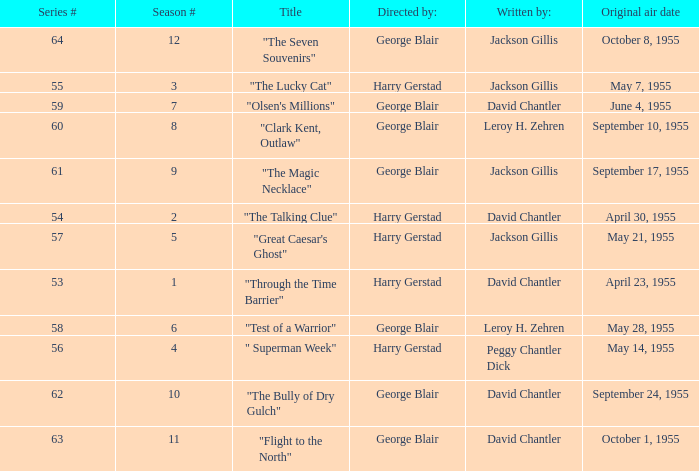What is the lowest number of series? 53.0. Give me the full table as a dictionary. {'header': ['Series #', 'Season #', 'Title', 'Directed by:', 'Written by:', 'Original air date'], 'rows': [['64', '12', '"The Seven Souvenirs"', 'George Blair', 'Jackson Gillis', 'October 8, 1955'], ['55', '3', '"The Lucky Cat"', 'Harry Gerstad', 'Jackson Gillis', 'May 7, 1955'], ['59', '7', '"Olsen\'s Millions"', 'George Blair', 'David Chantler', 'June 4, 1955'], ['60', '8', '"Clark Kent, Outlaw"', 'George Blair', 'Leroy H. Zehren', 'September 10, 1955'], ['61', '9', '"The Magic Necklace"', 'George Blair', 'Jackson Gillis', 'September 17, 1955'], ['54', '2', '"The Talking Clue"', 'Harry Gerstad', 'David Chantler', 'April 30, 1955'], ['57', '5', '"Great Caesar\'s Ghost"', 'Harry Gerstad', 'Jackson Gillis', 'May 21, 1955'], ['53', '1', '"Through the Time Barrier"', 'Harry Gerstad', 'David Chantler', 'April 23, 1955'], ['58', '6', '"Test of a Warrior"', 'George Blair', 'Leroy H. Zehren', 'May 28, 1955'], ['56', '4', '" Superman Week"', 'Harry Gerstad', 'Peggy Chantler Dick', 'May 14, 1955'], ['62', '10', '"The Bully of Dry Gulch"', 'George Blair', 'David Chantler', 'September 24, 1955'], ['63', '11', '"Flight to the North"', 'George Blair', 'David Chantler', 'October 1, 1955']]} 